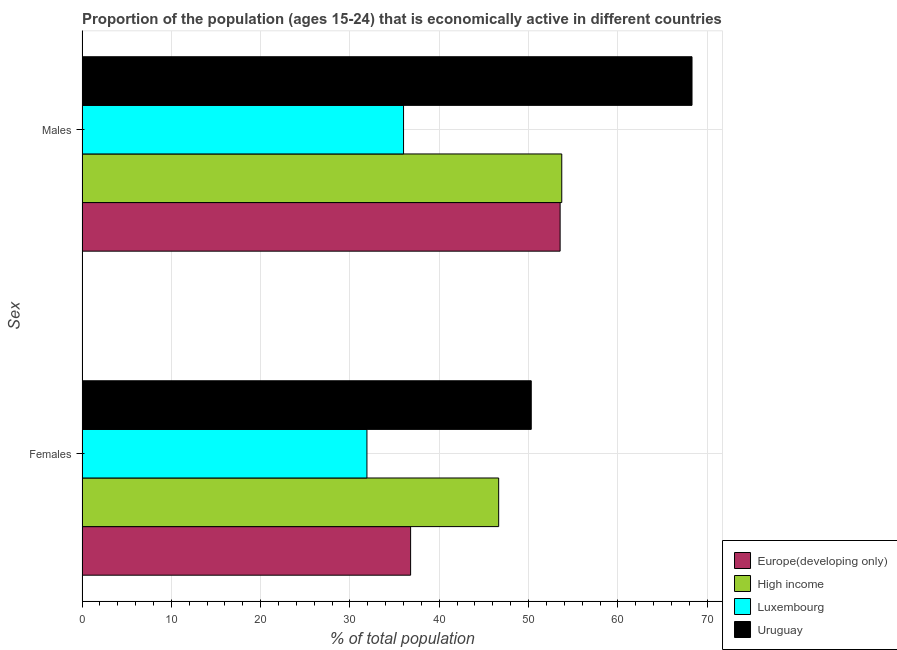How many groups of bars are there?
Make the answer very short. 2. Are the number of bars on each tick of the Y-axis equal?
Keep it short and to the point. Yes. How many bars are there on the 1st tick from the top?
Offer a terse response. 4. What is the label of the 2nd group of bars from the top?
Provide a succinct answer. Females. Across all countries, what is the maximum percentage of economically active female population?
Your answer should be very brief. 50.3. Across all countries, what is the minimum percentage of economically active female population?
Keep it short and to the point. 31.9. In which country was the percentage of economically active female population maximum?
Your answer should be very brief. Uruguay. In which country was the percentage of economically active female population minimum?
Give a very brief answer. Luxembourg. What is the total percentage of economically active male population in the graph?
Your answer should be compact. 211.55. What is the difference between the percentage of economically active male population in Uruguay and that in Europe(developing only)?
Offer a terse response. 14.77. What is the difference between the percentage of economically active female population in Luxembourg and the percentage of economically active male population in High income?
Ensure brevity in your answer.  -21.82. What is the average percentage of economically active female population per country?
Provide a succinct answer. 41.41. What is the difference between the percentage of economically active male population and percentage of economically active female population in High income?
Give a very brief answer. 7.06. What is the ratio of the percentage of economically active female population in Uruguay to that in High income?
Provide a short and direct response. 1.08. Is the percentage of economically active male population in Uruguay less than that in Luxembourg?
Your answer should be very brief. No. What does the 4th bar from the top in Females represents?
Ensure brevity in your answer.  Europe(developing only). How many bars are there?
Offer a very short reply. 8. What is the difference between two consecutive major ticks on the X-axis?
Offer a very short reply. 10. Does the graph contain any zero values?
Make the answer very short. No. How many legend labels are there?
Provide a short and direct response. 4. What is the title of the graph?
Ensure brevity in your answer.  Proportion of the population (ages 15-24) that is economically active in different countries. What is the label or title of the X-axis?
Offer a very short reply. % of total population. What is the label or title of the Y-axis?
Keep it short and to the point. Sex. What is the % of total population in Europe(developing only) in Females?
Keep it short and to the point. 36.79. What is the % of total population of High income in Females?
Your answer should be compact. 46.65. What is the % of total population of Luxembourg in Females?
Provide a succinct answer. 31.9. What is the % of total population of Uruguay in Females?
Provide a succinct answer. 50.3. What is the % of total population of Europe(developing only) in Males?
Provide a short and direct response. 53.53. What is the % of total population in High income in Males?
Give a very brief answer. 53.72. What is the % of total population of Uruguay in Males?
Offer a terse response. 68.3. Across all Sex, what is the maximum % of total population in Europe(developing only)?
Ensure brevity in your answer.  53.53. Across all Sex, what is the maximum % of total population in High income?
Provide a succinct answer. 53.72. Across all Sex, what is the maximum % of total population in Uruguay?
Your answer should be very brief. 68.3. Across all Sex, what is the minimum % of total population of Europe(developing only)?
Your answer should be compact. 36.79. Across all Sex, what is the minimum % of total population in High income?
Provide a succinct answer. 46.65. Across all Sex, what is the minimum % of total population of Luxembourg?
Keep it short and to the point. 31.9. Across all Sex, what is the minimum % of total population in Uruguay?
Give a very brief answer. 50.3. What is the total % of total population of Europe(developing only) in the graph?
Provide a succinct answer. 90.32. What is the total % of total population of High income in the graph?
Give a very brief answer. 100.37. What is the total % of total population of Luxembourg in the graph?
Ensure brevity in your answer.  67.9. What is the total % of total population of Uruguay in the graph?
Your answer should be compact. 118.6. What is the difference between the % of total population of Europe(developing only) in Females and that in Males?
Keep it short and to the point. -16.74. What is the difference between the % of total population in High income in Females and that in Males?
Provide a succinct answer. -7.06. What is the difference between the % of total population of Luxembourg in Females and that in Males?
Offer a very short reply. -4.1. What is the difference between the % of total population in Europe(developing only) in Females and the % of total population in High income in Males?
Offer a terse response. -16.93. What is the difference between the % of total population of Europe(developing only) in Females and the % of total population of Luxembourg in Males?
Make the answer very short. 0.79. What is the difference between the % of total population in Europe(developing only) in Females and the % of total population in Uruguay in Males?
Make the answer very short. -31.51. What is the difference between the % of total population in High income in Females and the % of total population in Luxembourg in Males?
Provide a succinct answer. 10.65. What is the difference between the % of total population in High income in Females and the % of total population in Uruguay in Males?
Ensure brevity in your answer.  -21.65. What is the difference between the % of total population in Luxembourg in Females and the % of total population in Uruguay in Males?
Offer a terse response. -36.4. What is the average % of total population in Europe(developing only) per Sex?
Provide a succinct answer. 45.16. What is the average % of total population in High income per Sex?
Your answer should be very brief. 50.18. What is the average % of total population of Luxembourg per Sex?
Ensure brevity in your answer.  33.95. What is the average % of total population of Uruguay per Sex?
Provide a succinct answer. 59.3. What is the difference between the % of total population of Europe(developing only) and % of total population of High income in Females?
Offer a terse response. -9.86. What is the difference between the % of total population of Europe(developing only) and % of total population of Luxembourg in Females?
Offer a terse response. 4.89. What is the difference between the % of total population in Europe(developing only) and % of total population in Uruguay in Females?
Ensure brevity in your answer.  -13.51. What is the difference between the % of total population of High income and % of total population of Luxembourg in Females?
Offer a very short reply. 14.75. What is the difference between the % of total population of High income and % of total population of Uruguay in Females?
Offer a very short reply. -3.65. What is the difference between the % of total population of Luxembourg and % of total population of Uruguay in Females?
Your answer should be very brief. -18.4. What is the difference between the % of total population in Europe(developing only) and % of total population in High income in Males?
Offer a very short reply. -0.18. What is the difference between the % of total population of Europe(developing only) and % of total population of Luxembourg in Males?
Give a very brief answer. 17.53. What is the difference between the % of total population in Europe(developing only) and % of total population in Uruguay in Males?
Offer a terse response. -14.77. What is the difference between the % of total population of High income and % of total population of Luxembourg in Males?
Offer a very short reply. 17.72. What is the difference between the % of total population in High income and % of total population in Uruguay in Males?
Offer a very short reply. -14.58. What is the difference between the % of total population in Luxembourg and % of total population in Uruguay in Males?
Keep it short and to the point. -32.3. What is the ratio of the % of total population in Europe(developing only) in Females to that in Males?
Provide a succinct answer. 0.69. What is the ratio of the % of total population in High income in Females to that in Males?
Give a very brief answer. 0.87. What is the ratio of the % of total population in Luxembourg in Females to that in Males?
Offer a very short reply. 0.89. What is the ratio of the % of total population of Uruguay in Females to that in Males?
Ensure brevity in your answer.  0.74. What is the difference between the highest and the second highest % of total population in Europe(developing only)?
Offer a terse response. 16.74. What is the difference between the highest and the second highest % of total population of High income?
Give a very brief answer. 7.06. What is the difference between the highest and the second highest % of total population of Luxembourg?
Give a very brief answer. 4.1. What is the difference between the highest and the second highest % of total population of Uruguay?
Your answer should be compact. 18. What is the difference between the highest and the lowest % of total population in Europe(developing only)?
Your response must be concise. 16.74. What is the difference between the highest and the lowest % of total population of High income?
Offer a terse response. 7.06. What is the difference between the highest and the lowest % of total population in Luxembourg?
Provide a succinct answer. 4.1. What is the difference between the highest and the lowest % of total population in Uruguay?
Your response must be concise. 18. 